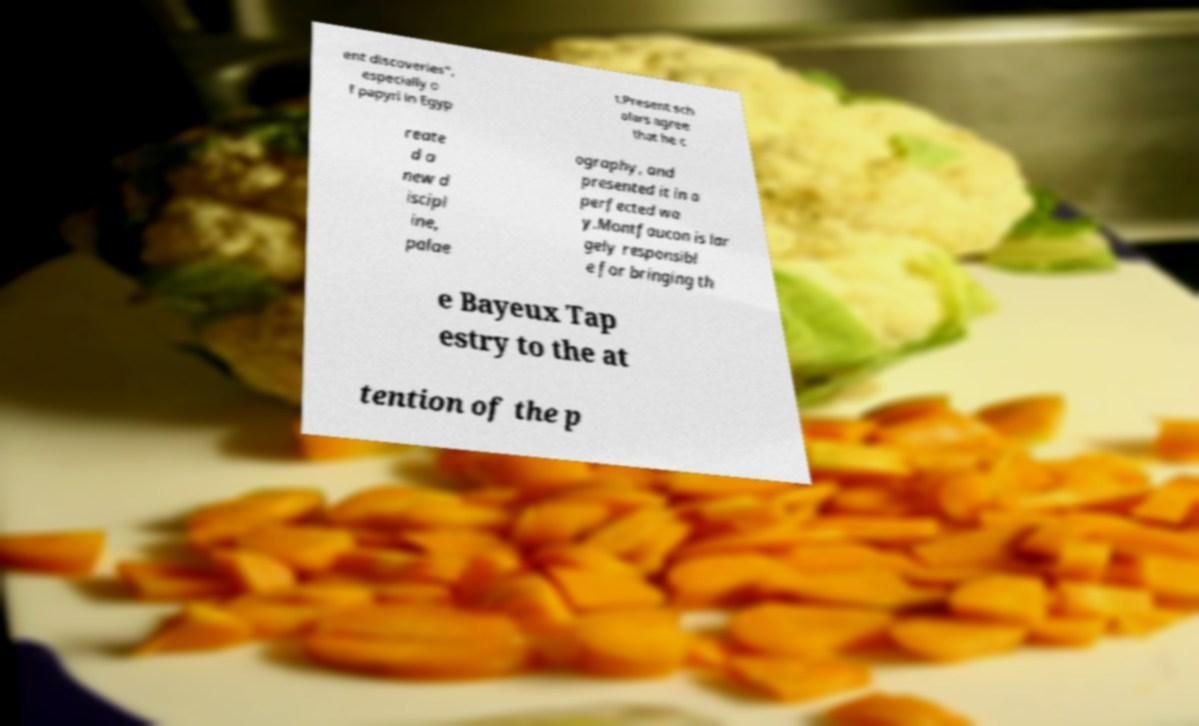Could you assist in decoding the text presented in this image and type it out clearly? ent discoveries", especially o f papyri in Egyp t.Present sch olars agree that he c reate d a new d iscipl ine, palae ography, and presented it in a perfected wa y.Montfaucon is lar gely responsibl e for bringing th e Bayeux Tap estry to the at tention of the p 